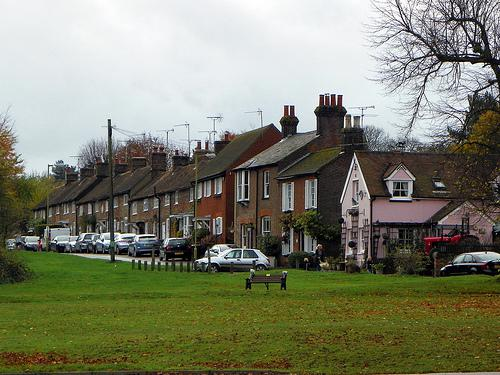Question: how are the cars?
Choices:
A. Moving.
B. Dented.
C. Getting gas.
D. Motionless.
Answer with the letter. Answer: D Question: what else is in the photo?
Choices:
A. Flowers.
B. Cars.
C. Houses.
D. Bikes.
Answer with the letter. Answer: C Question: when was the photo taken?
Choices:
A. Morning.
B. Evening.
C. Daytime.
D. Late night.
Answer with the letter. Answer: C Question: where photo taken?
Choices:
A. In an urban neighborhood.
B. On the farm.
C. In the mall.
D. At the beach.
Answer with the letter. Answer: A 